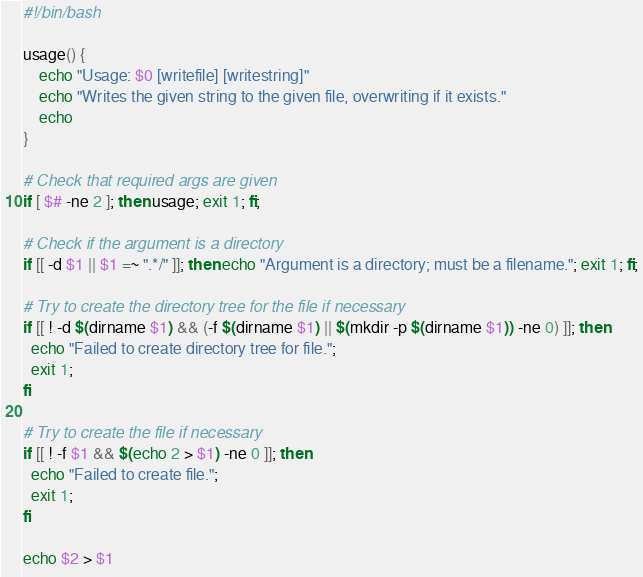<code> <loc_0><loc_0><loc_500><loc_500><_Bash_>#!/bin/bash

usage() {
    echo "Usage: $0 [writefile] [writestring]"
    echo "Writes the given string to the given file, overwriting if it exists."
    echo
}

# Check that required args are given
if [ $# -ne 2 ]; then usage; exit 1; fi;

# Check if the argument is a directory
if [[ -d $1 || $1 =~ ".*/" ]]; then echo "Argument is a directory; must be a filename."; exit 1; fi;

# Try to create the directory tree for the file if necessary
if [[ ! -d $(dirname $1) && (-f $(dirname $1) || $(mkdir -p $(dirname $1)) -ne 0) ]]; then
  echo "Failed to create directory tree for file.";
  exit 1;
fi

# Try to create the file if necessary
if [[ ! -f $1 && $(echo 2 > $1) -ne 0 ]]; then
  echo "Failed to create file.";
  exit 1;
fi

echo $2 > $1</code> 